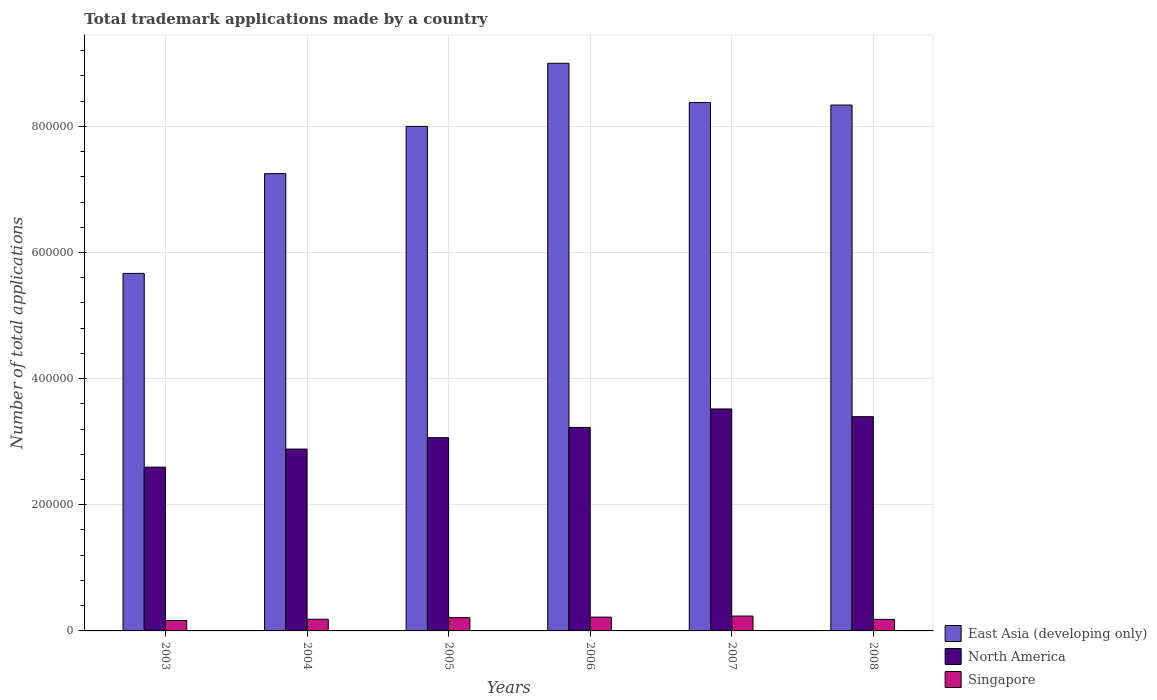How many different coloured bars are there?
Your response must be concise. 3. How many groups of bars are there?
Give a very brief answer. 6. Are the number of bars on each tick of the X-axis equal?
Your answer should be compact. Yes. What is the label of the 3rd group of bars from the left?
Offer a very short reply. 2005. In how many cases, is the number of bars for a given year not equal to the number of legend labels?
Ensure brevity in your answer.  0. What is the number of applications made by in East Asia (developing only) in 2004?
Provide a short and direct response. 7.25e+05. Across all years, what is the maximum number of applications made by in North America?
Give a very brief answer. 3.52e+05. Across all years, what is the minimum number of applications made by in North America?
Ensure brevity in your answer.  2.60e+05. In which year was the number of applications made by in North America minimum?
Your response must be concise. 2003. What is the total number of applications made by in Singapore in the graph?
Offer a very short reply. 1.20e+05. What is the difference between the number of applications made by in Singapore in 2003 and that in 2007?
Offer a very short reply. -7031. What is the difference between the number of applications made by in Singapore in 2003 and the number of applications made by in North America in 2006?
Give a very brief answer. -3.06e+05. What is the average number of applications made by in North America per year?
Make the answer very short. 3.11e+05. In the year 2004, what is the difference between the number of applications made by in Singapore and number of applications made by in North America?
Give a very brief answer. -2.70e+05. In how many years, is the number of applications made by in North America greater than 800000?
Offer a terse response. 0. What is the ratio of the number of applications made by in East Asia (developing only) in 2004 to that in 2006?
Make the answer very short. 0.81. What is the difference between the highest and the second highest number of applications made by in North America?
Offer a terse response. 1.22e+04. What is the difference between the highest and the lowest number of applications made by in Singapore?
Offer a very short reply. 7031. What does the 3rd bar from the left in 2008 represents?
Provide a succinct answer. Singapore. What does the 3rd bar from the right in 2004 represents?
Provide a short and direct response. East Asia (developing only). Is it the case that in every year, the sum of the number of applications made by in Singapore and number of applications made by in East Asia (developing only) is greater than the number of applications made by in North America?
Offer a very short reply. Yes. How many bars are there?
Offer a terse response. 18. What is the difference between two consecutive major ticks on the Y-axis?
Give a very brief answer. 2.00e+05. Does the graph contain grids?
Your response must be concise. Yes. What is the title of the graph?
Your answer should be compact. Total trademark applications made by a country. Does "Tanzania" appear as one of the legend labels in the graph?
Give a very brief answer. No. What is the label or title of the Y-axis?
Give a very brief answer. Number of total applications. What is the Number of total applications of East Asia (developing only) in 2003?
Provide a short and direct response. 5.67e+05. What is the Number of total applications in North America in 2003?
Offer a terse response. 2.60e+05. What is the Number of total applications in Singapore in 2003?
Your response must be concise. 1.65e+04. What is the Number of total applications of East Asia (developing only) in 2004?
Offer a very short reply. 7.25e+05. What is the Number of total applications of North America in 2004?
Keep it short and to the point. 2.88e+05. What is the Number of total applications of Singapore in 2004?
Make the answer very short. 1.86e+04. What is the Number of total applications in East Asia (developing only) in 2005?
Offer a terse response. 8.00e+05. What is the Number of total applications of North America in 2005?
Ensure brevity in your answer.  3.06e+05. What is the Number of total applications in Singapore in 2005?
Give a very brief answer. 2.11e+04. What is the Number of total applications in East Asia (developing only) in 2006?
Ensure brevity in your answer.  9.00e+05. What is the Number of total applications in North America in 2006?
Keep it short and to the point. 3.23e+05. What is the Number of total applications of Singapore in 2006?
Offer a terse response. 2.19e+04. What is the Number of total applications in East Asia (developing only) in 2007?
Provide a succinct answer. 8.38e+05. What is the Number of total applications of North America in 2007?
Provide a short and direct response. 3.52e+05. What is the Number of total applications in Singapore in 2007?
Give a very brief answer. 2.36e+04. What is the Number of total applications in East Asia (developing only) in 2008?
Offer a very short reply. 8.34e+05. What is the Number of total applications in North America in 2008?
Your answer should be very brief. 3.40e+05. What is the Number of total applications in Singapore in 2008?
Provide a short and direct response. 1.83e+04. Across all years, what is the maximum Number of total applications of East Asia (developing only)?
Ensure brevity in your answer.  9.00e+05. Across all years, what is the maximum Number of total applications in North America?
Your response must be concise. 3.52e+05. Across all years, what is the maximum Number of total applications in Singapore?
Ensure brevity in your answer.  2.36e+04. Across all years, what is the minimum Number of total applications of East Asia (developing only)?
Ensure brevity in your answer.  5.67e+05. Across all years, what is the minimum Number of total applications in North America?
Offer a terse response. 2.60e+05. Across all years, what is the minimum Number of total applications of Singapore?
Keep it short and to the point. 1.65e+04. What is the total Number of total applications in East Asia (developing only) in the graph?
Your answer should be compact. 4.66e+06. What is the total Number of total applications of North America in the graph?
Your answer should be compact. 1.87e+06. What is the total Number of total applications in Singapore in the graph?
Your answer should be very brief. 1.20e+05. What is the difference between the Number of total applications of East Asia (developing only) in 2003 and that in 2004?
Your answer should be very brief. -1.58e+05. What is the difference between the Number of total applications of North America in 2003 and that in 2004?
Ensure brevity in your answer.  -2.86e+04. What is the difference between the Number of total applications in Singapore in 2003 and that in 2004?
Give a very brief answer. -2017. What is the difference between the Number of total applications in East Asia (developing only) in 2003 and that in 2005?
Your answer should be very brief. -2.33e+05. What is the difference between the Number of total applications of North America in 2003 and that in 2005?
Your answer should be very brief. -4.67e+04. What is the difference between the Number of total applications in Singapore in 2003 and that in 2005?
Keep it short and to the point. -4558. What is the difference between the Number of total applications of East Asia (developing only) in 2003 and that in 2006?
Offer a terse response. -3.33e+05. What is the difference between the Number of total applications in North America in 2003 and that in 2006?
Make the answer very short. -6.29e+04. What is the difference between the Number of total applications of Singapore in 2003 and that in 2006?
Offer a terse response. -5331. What is the difference between the Number of total applications in East Asia (developing only) in 2003 and that in 2007?
Offer a very short reply. -2.71e+05. What is the difference between the Number of total applications in North America in 2003 and that in 2007?
Your answer should be very brief. -9.22e+04. What is the difference between the Number of total applications in Singapore in 2003 and that in 2007?
Make the answer very short. -7031. What is the difference between the Number of total applications in East Asia (developing only) in 2003 and that in 2008?
Your answer should be very brief. -2.67e+05. What is the difference between the Number of total applications in North America in 2003 and that in 2008?
Ensure brevity in your answer.  -8.00e+04. What is the difference between the Number of total applications in Singapore in 2003 and that in 2008?
Provide a short and direct response. -1730. What is the difference between the Number of total applications of East Asia (developing only) in 2004 and that in 2005?
Make the answer very short. -7.49e+04. What is the difference between the Number of total applications in North America in 2004 and that in 2005?
Provide a succinct answer. -1.80e+04. What is the difference between the Number of total applications of Singapore in 2004 and that in 2005?
Make the answer very short. -2541. What is the difference between the Number of total applications of East Asia (developing only) in 2004 and that in 2006?
Give a very brief answer. -1.75e+05. What is the difference between the Number of total applications of North America in 2004 and that in 2006?
Offer a terse response. -3.43e+04. What is the difference between the Number of total applications of Singapore in 2004 and that in 2006?
Keep it short and to the point. -3314. What is the difference between the Number of total applications of East Asia (developing only) in 2004 and that in 2007?
Your answer should be very brief. -1.13e+05. What is the difference between the Number of total applications in North America in 2004 and that in 2007?
Offer a very short reply. -6.36e+04. What is the difference between the Number of total applications of Singapore in 2004 and that in 2007?
Make the answer very short. -5014. What is the difference between the Number of total applications of East Asia (developing only) in 2004 and that in 2008?
Provide a succinct answer. -1.09e+05. What is the difference between the Number of total applications in North America in 2004 and that in 2008?
Ensure brevity in your answer.  -5.14e+04. What is the difference between the Number of total applications of Singapore in 2004 and that in 2008?
Make the answer very short. 287. What is the difference between the Number of total applications of East Asia (developing only) in 2005 and that in 2006?
Your answer should be very brief. -1.00e+05. What is the difference between the Number of total applications in North America in 2005 and that in 2006?
Offer a terse response. -1.63e+04. What is the difference between the Number of total applications of Singapore in 2005 and that in 2006?
Provide a short and direct response. -773. What is the difference between the Number of total applications in East Asia (developing only) in 2005 and that in 2007?
Provide a short and direct response. -3.79e+04. What is the difference between the Number of total applications in North America in 2005 and that in 2007?
Your answer should be compact. -4.55e+04. What is the difference between the Number of total applications in Singapore in 2005 and that in 2007?
Provide a succinct answer. -2473. What is the difference between the Number of total applications in East Asia (developing only) in 2005 and that in 2008?
Your answer should be very brief. -3.39e+04. What is the difference between the Number of total applications in North America in 2005 and that in 2008?
Make the answer very short. -3.33e+04. What is the difference between the Number of total applications of Singapore in 2005 and that in 2008?
Offer a terse response. 2828. What is the difference between the Number of total applications of East Asia (developing only) in 2006 and that in 2007?
Ensure brevity in your answer.  6.22e+04. What is the difference between the Number of total applications in North America in 2006 and that in 2007?
Keep it short and to the point. -2.93e+04. What is the difference between the Number of total applications of Singapore in 2006 and that in 2007?
Provide a succinct answer. -1700. What is the difference between the Number of total applications of East Asia (developing only) in 2006 and that in 2008?
Provide a succinct answer. 6.62e+04. What is the difference between the Number of total applications of North America in 2006 and that in 2008?
Provide a short and direct response. -1.71e+04. What is the difference between the Number of total applications in Singapore in 2006 and that in 2008?
Provide a short and direct response. 3601. What is the difference between the Number of total applications in East Asia (developing only) in 2007 and that in 2008?
Make the answer very short. 4035. What is the difference between the Number of total applications in North America in 2007 and that in 2008?
Offer a terse response. 1.22e+04. What is the difference between the Number of total applications in Singapore in 2007 and that in 2008?
Ensure brevity in your answer.  5301. What is the difference between the Number of total applications of East Asia (developing only) in 2003 and the Number of total applications of North America in 2004?
Keep it short and to the point. 2.79e+05. What is the difference between the Number of total applications of East Asia (developing only) in 2003 and the Number of total applications of Singapore in 2004?
Provide a succinct answer. 5.48e+05. What is the difference between the Number of total applications of North America in 2003 and the Number of total applications of Singapore in 2004?
Your answer should be compact. 2.41e+05. What is the difference between the Number of total applications in East Asia (developing only) in 2003 and the Number of total applications in North America in 2005?
Provide a succinct answer. 2.60e+05. What is the difference between the Number of total applications in East Asia (developing only) in 2003 and the Number of total applications in Singapore in 2005?
Give a very brief answer. 5.46e+05. What is the difference between the Number of total applications in North America in 2003 and the Number of total applications in Singapore in 2005?
Make the answer very short. 2.39e+05. What is the difference between the Number of total applications in East Asia (developing only) in 2003 and the Number of total applications in North America in 2006?
Offer a terse response. 2.44e+05. What is the difference between the Number of total applications in East Asia (developing only) in 2003 and the Number of total applications in Singapore in 2006?
Offer a very short reply. 5.45e+05. What is the difference between the Number of total applications of North America in 2003 and the Number of total applications of Singapore in 2006?
Provide a succinct answer. 2.38e+05. What is the difference between the Number of total applications of East Asia (developing only) in 2003 and the Number of total applications of North America in 2007?
Give a very brief answer. 2.15e+05. What is the difference between the Number of total applications in East Asia (developing only) in 2003 and the Number of total applications in Singapore in 2007?
Provide a short and direct response. 5.43e+05. What is the difference between the Number of total applications of North America in 2003 and the Number of total applications of Singapore in 2007?
Your response must be concise. 2.36e+05. What is the difference between the Number of total applications of East Asia (developing only) in 2003 and the Number of total applications of North America in 2008?
Ensure brevity in your answer.  2.27e+05. What is the difference between the Number of total applications of East Asia (developing only) in 2003 and the Number of total applications of Singapore in 2008?
Your answer should be very brief. 5.49e+05. What is the difference between the Number of total applications in North America in 2003 and the Number of total applications in Singapore in 2008?
Provide a short and direct response. 2.41e+05. What is the difference between the Number of total applications in East Asia (developing only) in 2004 and the Number of total applications in North America in 2005?
Give a very brief answer. 4.19e+05. What is the difference between the Number of total applications of East Asia (developing only) in 2004 and the Number of total applications of Singapore in 2005?
Your response must be concise. 7.04e+05. What is the difference between the Number of total applications of North America in 2004 and the Number of total applications of Singapore in 2005?
Provide a succinct answer. 2.67e+05. What is the difference between the Number of total applications of East Asia (developing only) in 2004 and the Number of total applications of North America in 2006?
Your response must be concise. 4.02e+05. What is the difference between the Number of total applications in East Asia (developing only) in 2004 and the Number of total applications in Singapore in 2006?
Provide a succinct answer. 7.03e+05. What is the difference between the Number of total applications in North America in 2004 and the Number of total applications in Singapore in 2006?
Your answer should be very brief. 2.66e+05. What is the difference between the Number of total applications of East Asia (developing only) in 2004 and the Number of total applications of North America in 2007?
Your answer should be compact. 3.73e+05. What is the difference between the Number of total applications in East Asia (developing only) in 2004 and the Number of total applications in Singapore in 2007?
Make the answer very short. 7.01e+05. What is the difference between the Number of total applications of North America in 2004 and the Number of total applications of Singapore in 2007?
Provide a succinct answer. 2.65e+05. What is the difference between the Number of total applications of East Asia (developing only) in 2004 and the Number of total applications of North America in 2008?
Ensure brevity in your answer.  3.85e+05. What is the difference between the Number of total applications of East Asia (developing only) in 2004 and the Number of total applications of Singapore in 2008?
Your answer should be compact. 7.07e+05. What is the difference between the Number of total applications of North America in 2004 and the Number of total applications of Singapore in 2008?
Your answer should be compact. 2.70e+05. What is the difference between the Number of total applications of East Asia (developing only) in 2005 and the Number of total applications of North America in 2006?
Ensure brevity in your answer.  4.77e+05. What is the difference between the Number of total applications in East Asia (developing only) in 2005 and the Number of total applications in Singapore in 2006?
Keep it short and to the point. 7.78e+05. What is the difference between the Number of total applications in North America in 2005 and the Number of total applications in Singapore in 2006?
Provide a succinct answer. 2.84e+05. What is the difference between the Number of total applications in East Asia (developing only) in 2005 and the Number of total applications in North America in 2007?
Offer a terse response. 4.48e+05. What is the difference between the Number of total applications in East Asia (developing only) in 2005 and the Number of total applications in Singapore in 2007?
Give a very brief answer. 7.76e+05. What is the difference between the Number of total applications in North America in 2005 and the Number of total applications in Singapore in 2007?
Make the answer very short. 2.83e+05. What is the difference between the Number of total applications of East Asia (developing only) in 2005 and the Number of total applications of North America in 2008?
Provide a short and direct response. 4.60e+05. What is the difference between the Number of total applications in East Asia (developing only) in 2005 and the Number of total applications in Singapore in 2008?
Your answer should be very brief. 7.82e+05. What is the difference between the Number of total applications in North America in 2005 and the Number of total applications in Singapore in 2008?
Your response must be concise. 2.88e+05. What is the difference between the Number of total applications of East Asia (developing only) in 2006 and the Number of total applications of North America in 2007?
Your response must be concise. 5.48e+05. What is the difference between the Number of total applications of East Asia (developing only) in 2006 and the Number of total applications of Singapore in 2007?
Provide a short and direct response. 8.76e+05. What is the difference between the Number of total applications of North America in 2006 and the Number of total applications of Singapore in 2007?
Ensure brevity in your answer.  2.99e+05. What is the difference between the Number of total applications in East Asia (developing only) in 2006 and the Number of total applications in North America in 2008?
Offer a terse response. 5.60e+05. What is the difference between the Number of total applications in East Asia (developing only) in 2006 and the Number of total applications in Singapore in 2008?
Make the answer very short. 8.82e+05. What is the difference between the Number of total applications of North America in 2006 and the Number of total applications of Singapore in 2008?
Ensure brevity in your answer.  3.04e+05. What is the difference between the Number of total applications in East Asia (developing only) in 2007 and the Number of total applications in North America in 2008?
Give a very brief answer. 4.98e+05. What is the difference between the Number of total applications in East Asia (developing only) in 2007 and the Number of total applications in Singapore in 2008?
Your answer should be compact. 8.19e+05. What is the difference between the Number of total applications of North America in 2007 and the Number of total applications of Singapore in 2008?
Keep it short and to the point. 3.34e+05. What is the average Number of total applications in East Asia (developing only) per year?
Offer a terse response. 7.77e+05. What is the average Number of total applications in North America per year?
Provide a succinct answer. 3.11e+05. What is the average Number of total applications of Singapore per year?
Your response must be concise. 2.00e+04. In the year 2003, what is the difference between the Number of total applications of East Asia (developing only) and Number of total applications of North America?
Your answer should be very brief. 3.07e+05. In the year 2003, what is the difference between the Number of total applications of East Asia (developing only) and Number of total applications of Singapore?
Your response must be concise. 5.50e+05. In the year 2003, what is the difference between the Number of total applications in North America and Number of total applications in Singapore?
Your response must be concise. 2.43e+05. In the year 2004, what is the difference between the Number of total applications in East Asia (developing only) and Number of total applications in North America?
Provide a short and direct response. 4.37e+05. In the year 2004, what is the difference between the Number of total applications of East Asia (developing only) and Number of total applications of Singapore?
Your answer should be compact. 7.06e+05. In the year 2004, what is the difference between the Number of total applications of North America and Number of total applications of Singapore?
Provide a short and direct response. 2.70e+05. In the year 2005, what is the difference between the Number of total applications of East Asia (developing only) and Number of total applications of North America?
Keep it short and to the point. 4.94e+05. In the year 2005, what is the difference between the Number of total applications of East Asia (developing only) and Number of total applications of Singapore?
Make the answer very short. 7.79e+05. In the year 2005, what is the difference between the Number of total applications in North America and Number of total applications in Singapore?
Your answer should be very brief. 2.85e+05. In the year 2006, what is the difference between the Number of total applications in East Asia (developing only) and Number of total applications in North America?
Make the answer very short. 5.77e+05. In the year 2006, what is the difference between the Number of total applications of East Asia (developing only) and Number of total applications of Singapore?
Your response must be concise. 8.78e+05. In the year 2006, what is the difference between the Number of total applications of North America and Number of total applications of Singapore?
Make the answer very short. 3.01e+05. In the year 2007, what is the difference between the Number of total applications of East Asia (developing only) and Number of total applications of North America?
Make the answer very short. 4.86e+05. In the year 2007, what is the difference between the Number of total applications in East Asia (developing only) and Number of total applications in Singapore?
Your answer should be very brief. 8.14e+05. In the year 2007, what is the difference between the Number of total applications of North America and Number of total applications of Singapore?
Offer a very short reply. 3.28e+05. In the year 2008, what is the difference between the Number of total applications of East Asia (developing only) and Number of total applications of North America?
Offer a terse response. 4.94e+05. In the year 2008, what is the difference between the Number of total applications of East Asia (developing only) and Number of total applications of Singapore?
Make the answer very short. 8.15e+05. In the year 2008, what is the difference between the Number of total applications in North America and Number of total applications in Singapore?
Provide a succinct answer. 3.21e+05. What is the ratio of the Number of total applications of East Asia (developing only) in 2003 to that in 2004?
Your answer should be compact. 0.78. What is the ratio of the Number of total applications in North America in 2003 to that in 2004?
Offer a very short reply. 0.9. What is the ratio of the Number of total applications in Singapore in 2003 to that in 2004?
Ensure brevity in your answer.  0.89. What is the ratio of the Number of total applications of East Asia (developing only) in 2003 to that in 2005?
Offer a terse response. 0.71. What is the ratio of the Number of total applications in North America in 2003 to that in 2005?
Provide a succinct answer. 0.85. What is the ratio of the Number of total applications of Singapore in 2003 to that in 2005?
Ensure brevity in your answer.  0.78. What is the ratio of the Number of total applications in East Asia (developing only) in 2003 to that in 2006?
Ensure brevity in your answer.  0.63. What is the ratio of the Number of total applications of North America in 2003 to that in 2006?
Your response must be concise. 0.8. What is the ratio of the Number of total applications in Singapore in 2003 to that in 2006?
Provide a succinct answer. 0.76. What is the ratio of the Number of total applications in East Asia (developing only) in 2003 to that in 2007?
Keep it short and to the point. 0.68. What is the ratio of the Number of total applications of North America in 2003 to that in 2007?
Ensure brevity in your answer.  0.74. What is the ratio of the Number of total applications of Singapore in 2003 to that in 2007?
Provide a short and direct response. 0.7. What is the ratio of the Number of total applications in East Asia (developing only) in 2003 to that in 2008?
Offer a very short reply. 0.68. What is the ratio of the Number of total applications in North America in 2003 to that in 2008?
Offer a terse response. 0.76. What is the ratio of the Number of total applications in Singapore in 2003 to that in 2008?
Your answer should be compact. 0.91. What is the ratio of the Number of total applications of East Asia (developing only) in 2004 to that in 2005?
Provide a succinct answer. 0.91. What is the ratio of the Number of total applications in North America in 2004 to that in 2005?
Offer a very short reply. 0.94. What is the ratio of the Number of total applications of Singapore in 2004 to that in 2005?
Provide a short and direct response. 0.88. What is the ratio of the Number of total applications in East Asia (developing only) in 2004 to that in 2006?
Your answer should be very brief. 0.81. What is the ratio of the Number of total applications of North America in 2004 to that in 2006?
Offer a terse response. 0.89. What is the ratio of the Number of total applications of Singapore in 2004 to that in 2006?
Provide a succinct answer. 0.85. What is the ratio of the Number of total applications in East Asia (developing only) in 2004 to that in 2007?
Your response must be concise. 0.87. What is the ratio of the Number of total applications of North America in 2004 to that in 2007?
Make the answer very short. 0.82. What is the ratio of the Number of total applications of Singapore in 2004 to that in 2007?
Your answer should be compact. 0.79. What is the ratio of the Number of total applications of East Asia (developing only) in 2004 to that in 2008?
Give a very brief answer. 0.87. What is the ratio of the Number of total applications of North America in 2004 to that in 2008?
Keep it short and to the point. 0.85. What is the ratio of the Number of total applications in Singapore in 2004 to that in 2008?
Provide a short and direct response. 1.02. What is the ratio of the Number of total applications of East Asia (developing only) in 2005 to that in 2006?
Provide a succinct answer. 0.89. What is the ratio of the Number of total applications of North America in 2005 to that in 2006?
Provide a succinct answer. 0.95. What is the ratio of the Number of total applications in Singapore in 2005 to that in 2006?
Offer a terse response. 0.96. What is the ratio of the Number of total applications in East Asia (developing only) in 2005 to that in 2007?
Give a very brief answer. 0.95. What is the ratio of the Number of total applications in North America in 2005 to that in 2007?
Give a very brief answer. 0.87. What is the ratio of the Number of total applications in Singapore in 2005 to that in 2007?
Give a very brief answer. 0.9. What is the ratio of the Number of total applications of East Asia (developing only) in 2005 to that in 2008?
Provide a succinct answer. 0.96. What is the ratio of the Number of total applications of North America in 2005 to that in 2008?
Provide a succinct answer. 0.9. What is the ratio of the Number of total applications of Singapore in 2005 to that in 2008?
Make the answer very short. 1.15. What is the ratio of the Number of total applications in East Asia (developing only) in 2006 to that in 2007?
Make the answer very short. 1.07. What is the ratio of the Number of total applications in North America in 2006 to that in 2007?
Provide a succinct answer. 0.92. What is the ratio of the Number of total applications of Singapore in 2006 to that in 2007?
Make the answer very short. 0.93. What is the ratio of the Number of total applications of East Asia (developing only) in 2006 to that in 2008?
Offer a very short reply. 1.08. What is the ratio of the Number of total applications of North America in 2006 to that in 2008?
Offer a terse response. 0.95. What is the ratio of the Number of total applications in Singapore in 2006 to that in 2008?
Ensure brevity in your answer.  1.2. What is the ratio of the Number of total applications of North America in 2007 to that in 2008?
Offer a very short reply. 1.04. What is the ratio of the Number of total applications in Singapore in 2007 to that in 2008?
Provide a succinct answer. 1.29. What is the difference between the highest and the second highest Number of total applications of East Asia (developing only)?
Provide a succinct answer. 6.22e+04. What is the difference between the highest and the second highest Number of total applications in North America?
Your response must be concise. 1.22e+04. What is the difference between the highest and the second highest Number of total applications in Singapore?
Provide a short and direct response. 1700. What is the difference between the highest and the lowest Number of total applications in East Asia (developing only)?
Provide a succinct answer. 3.33e+05. What is the difference between the highest and the lowest Number of total applications of North America?
Provide a short and direct response. 9.22e+04. What is the difference between the highest and the lowest Number of total applications in Singapore?
Make the answer very short. 7031. 